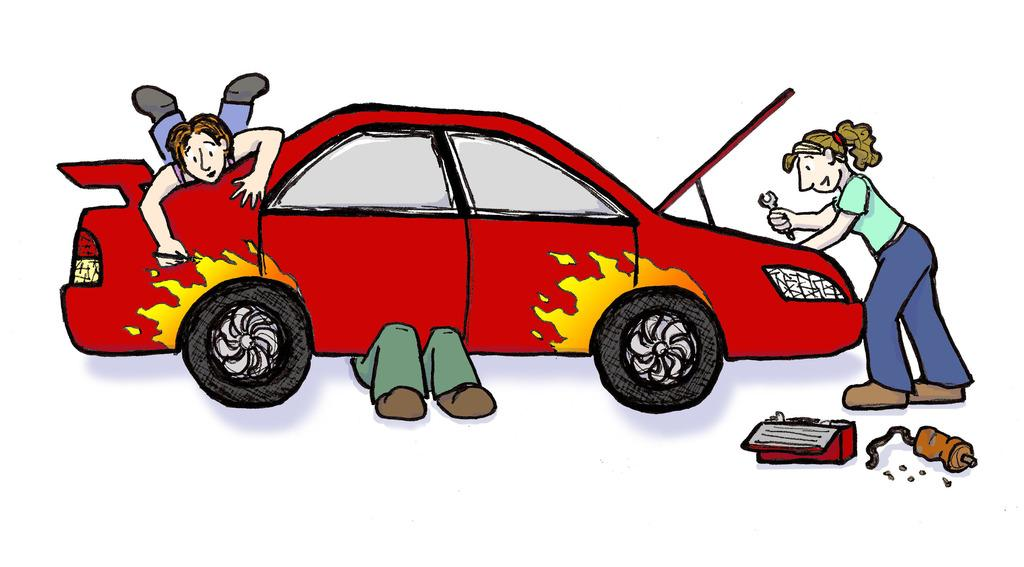What is depicted in the drawing in the image? There is a drawing of a car in the image. Who else is present in the image besides the car? There is a group of people in the image. Can you describe the group of people? There is a woman in the group of people. What is the woman holding in her hand? The woman is holding a wrench in her hand. What type of request does the fireman make in the image? There is no fireman present in the image, so it is not possible to answer that question. 